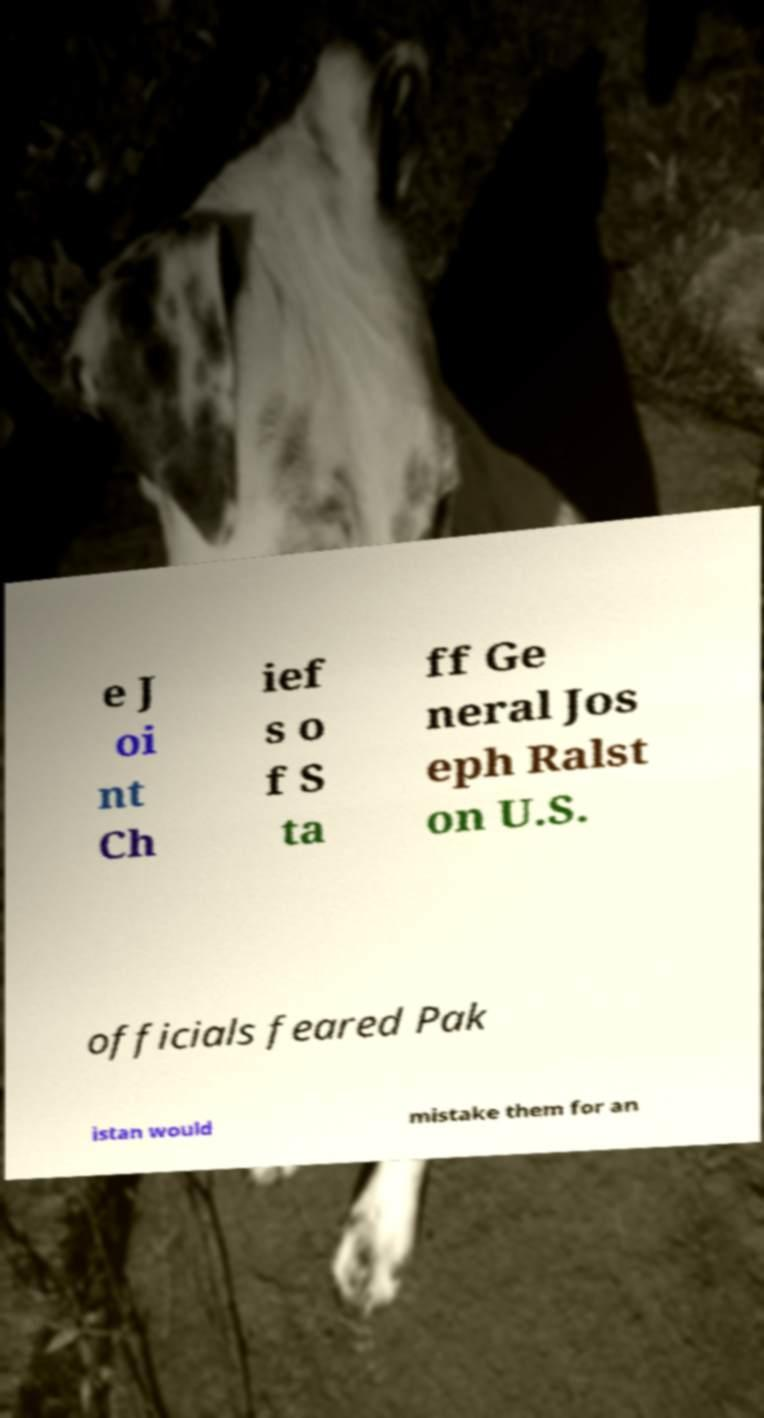Please identify and transcribe the text found in this image. e J oi nt Ch ief s o f S ta ff Ge neral Jos eph Ralst on U.S. officials feared Pak istan would mistake them for an 